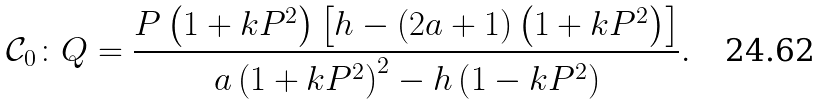Convert formula to latex. <formula><loc_0><loc_0><loc_500><loc_500>\mathcal { C } _ { 0 } \colon Q = \frac { P \left ( 1 + k P ^ { 2 } \right ) \left [ h - \left ( 2 a + 1 \right ) \left ( 1 + k P ^ { 2 } \right ) \right ] } { a \left ( 1 + k P ^ { 2 } \right ) ^ { 2 } - h \left ( 1 - k P ^ { 2 } \right ) } .</formula> 